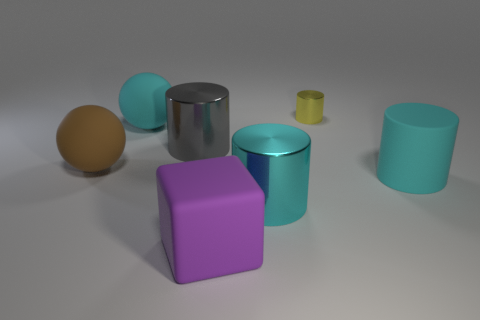Is there any object that stands out due to its color, and if so, what can you tell me about it? The purple cube stands out because of its vibrant color that contrasts with the more muted tones of the other objects in the image. It has a distinctly solid and geometric shape, which also makes it visually striking compared to the rounded objects. 